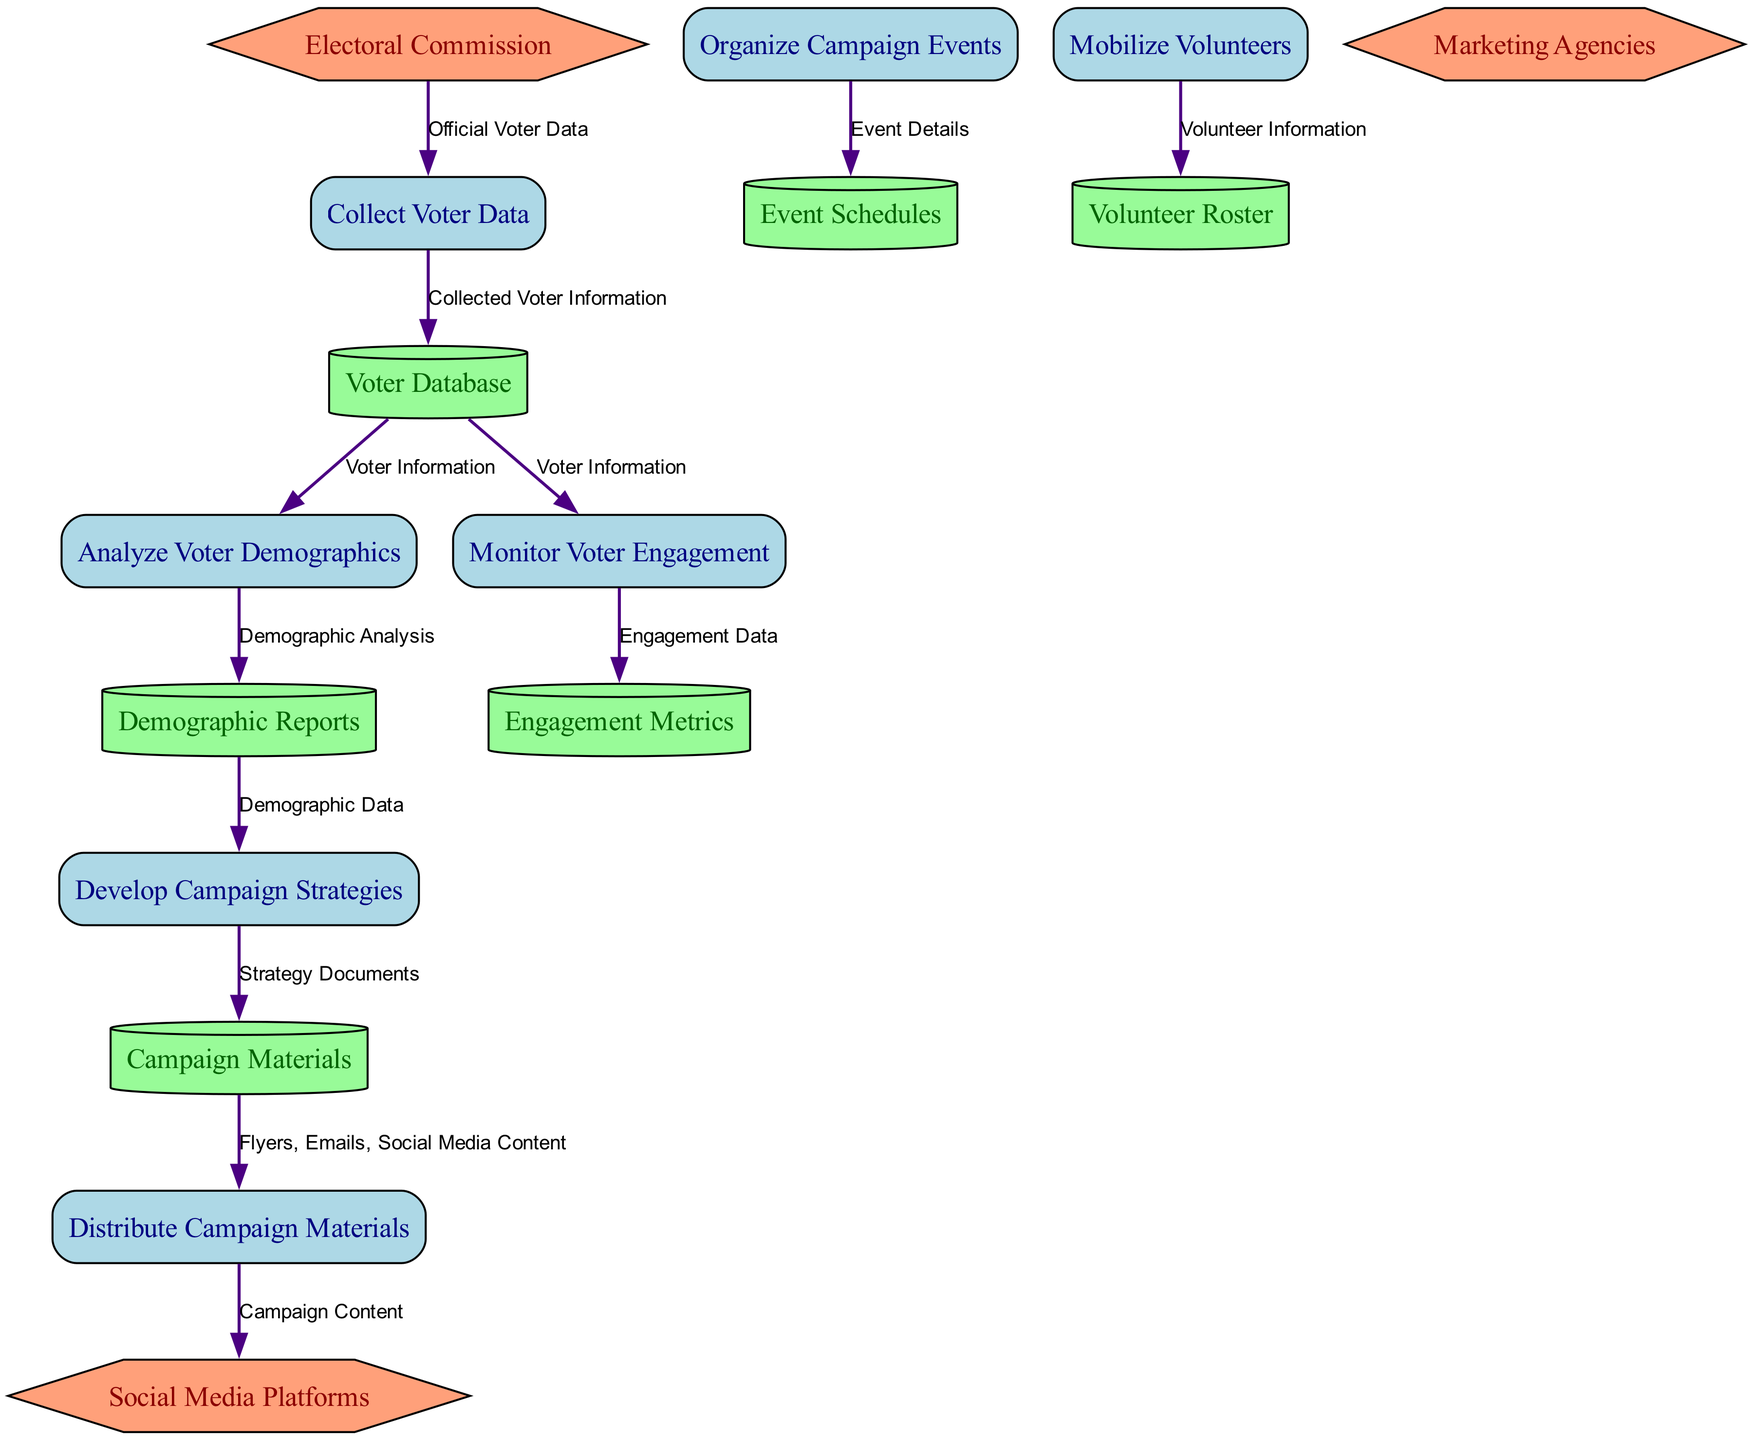What is the first process in the diagram? The diagram lists the process names, starting with "Collect Voter Data" at the top. Since it is the first process in the flow, it is identified as the initial step.
Answer: Collect Voter Data How many data stores are present in the diagram? The diagram contains a total of six distinct data stores, each identified clearly with a specific function regarding the voter information or campaign materials.
Answer: 6 What data flows from "Distribute Campaign Materials" to "Social Media Platforms"? The flow of data from "Distribute Campaign Materials" to "Social Media Platforms" is labeled "Campaign Content," which indicates what specific information is shared through social media.
Answer: Campaign Content Which external entity provides official voter registration data? The external entity responsible for supplying official voter registration data is the "Electoral Commission," as shown in the diagram linking it to the process of collecting voter data.
Answer: Electoral Commission Which process uses "Engagement Data" as input? The process that utilizes "Engagement Data" as input is "Monitor Voter Engagement," which examines how voters interact with the campaign materials and events.
Answer: Monitor Voter Engagement What is the connection between "Analyze Voter Demographics" and "Demographic Reports"? The connection is a data flow labeled "Demographic Analysis," meaning that the analysis performed in the "Analyze Voter Demographics" process generates insights that are stored in "Demographic Reports."
Answer: Demographic Analysis What type of materials is distributed in the "Distribute Campaign Materials" process? The materials distributed in this process include "Flyers, Emails, Social Media Content," which are various forms of outreach to the voters.
Answer: Flyers, Emails, Social Media Content How many processes follow the "Develop Campaign Strategies" process? After analyzing the diagram, it is clear that the "Develop Campaign Strategies" process is followed by two processes: "Distribute Campaign Materials" and "Organize Campaign Events."
Answer: 2 What data do "Mobilize Volunteers" and "Volunteer Roster" share? The data shared by the "Mobilize Volunteers" process with the "Volunteer Roster" is "Volunteer Information," which includes details about the volunteers involved in the campaign.
Answer: Volunteer Information 